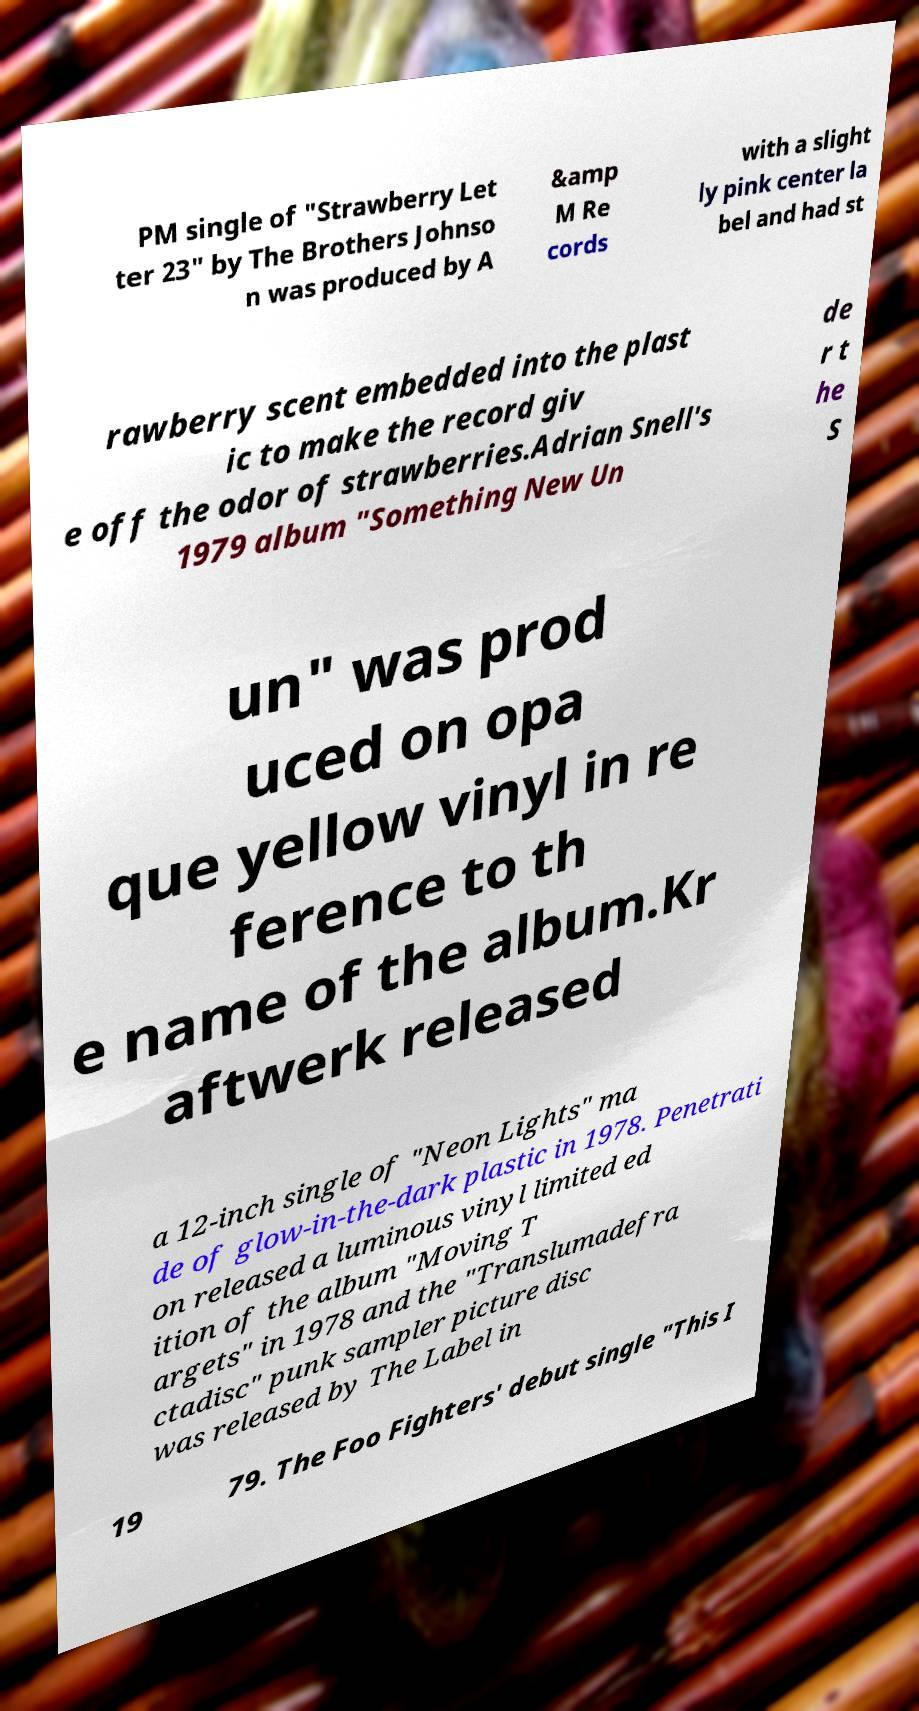I need the written content from this picture converted into text. Can you do that? PM single of "Strawberry Let ter 23" by The Brothers Johnso n was produced by A &amp M Re cords with a slight ly pink center la bel and had st rawberry scent embedded into the plast ic to make the record giv e off the odor of strawberries.Adrian Snell's 1979 album "Something New Un de r t he S un" was prod uced on opa que yellow vinyl in re ference to th e name of the album.Kr aftwerk released a 12-inch single of "Neon Lights" ma de of glow-in-the-dark plastic in 1978. Penetrati on released a luminous vinyl limited ed ition of the album "Moving T argets" in 1978 and the "Translumadefra ctadisc" punk sampler picture disc was released by The Label in 19 79. The Foo Fighters' debut single "This I 